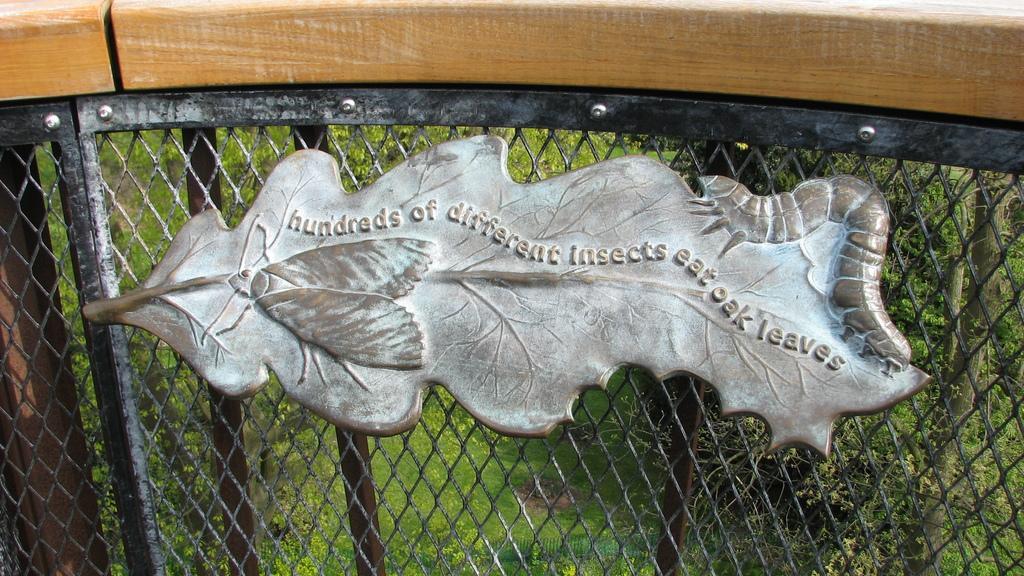Could you give a brief overview of what you see in this image? In the a part of the railing to it, we can see a leaf design on it, we can see written as hundreds of different insects eat away the oak leaves and from the railing we can see the grass surface. 